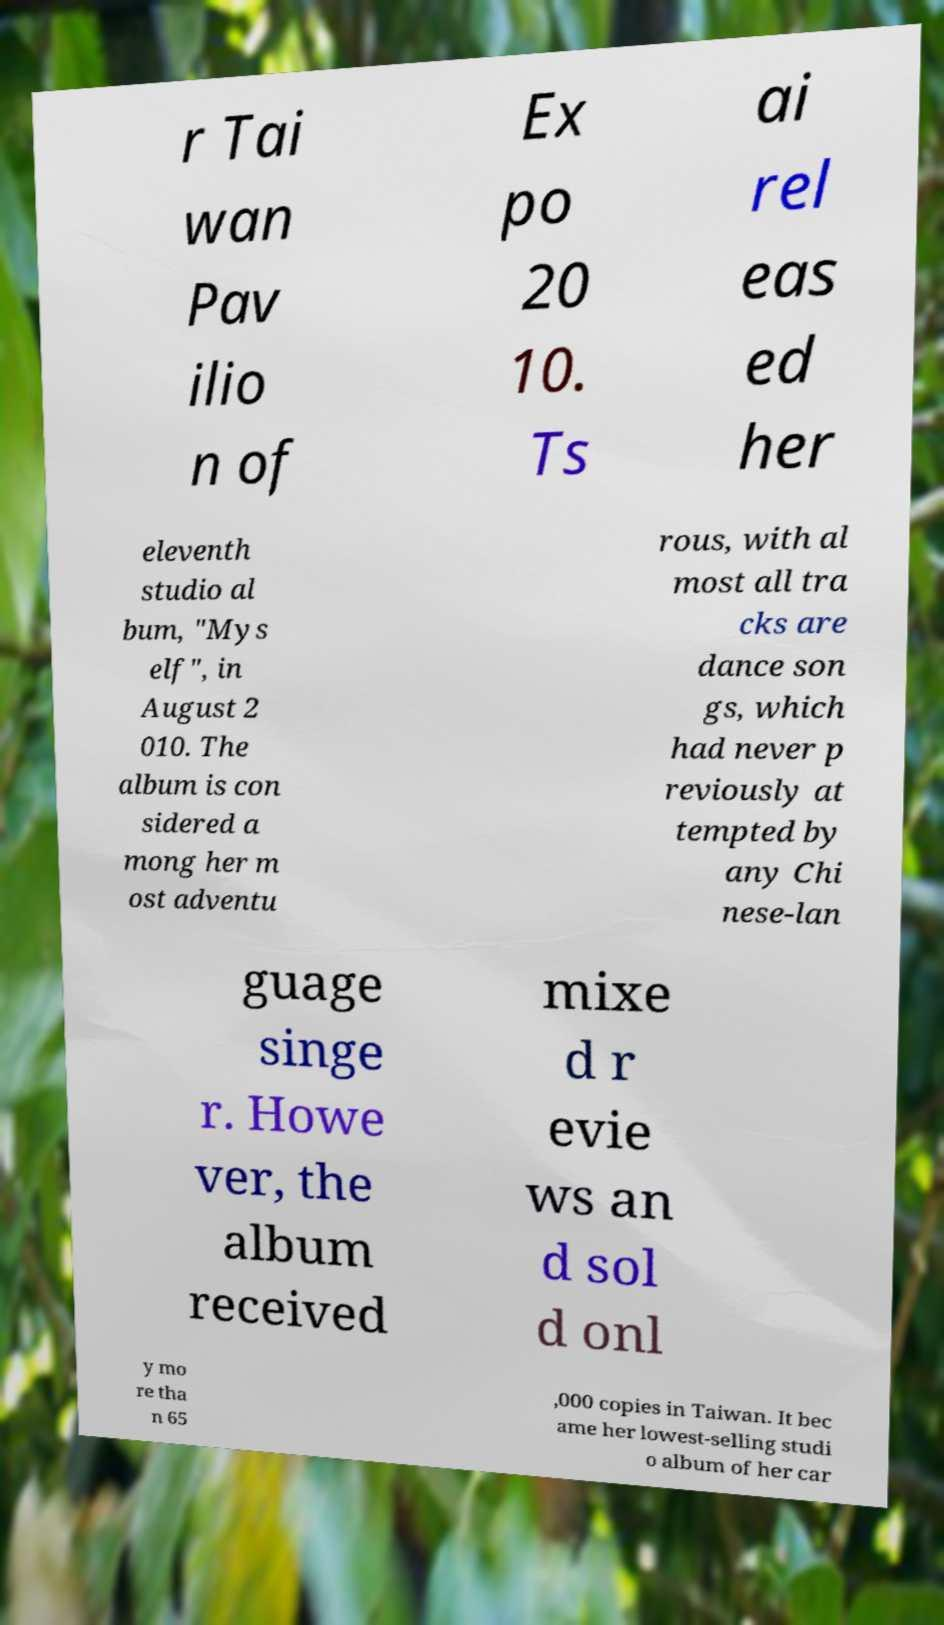Could you assist in decoding the text presented in this image and type it out clearly? r Tai wan Pav ilio n of Ex po 20 10. Ts ai rel eas ed her eleventh studio al bum, "Mys elf", in August 2 010. The album is con sidered a mong her m ost adventu rous, with al most all tra cks are dance son gs, which had never p reviously at tempted by any Chi nese-lan guage singe r. Howe ver, the album received mixe d r evie ws an d sol d onl y mo re tha n 65 ,000 copies in Taiwan. It bec ame her lowest-selling studi o album of her car 